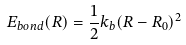<formula> <loc_0><loc_0><loc_500><loc_500>E _ { b o n d } ( R ) = \frac { 1 } { 2 } k _ { b } ( R - R _ { 0 } ) ^ { 2 }</formula> 